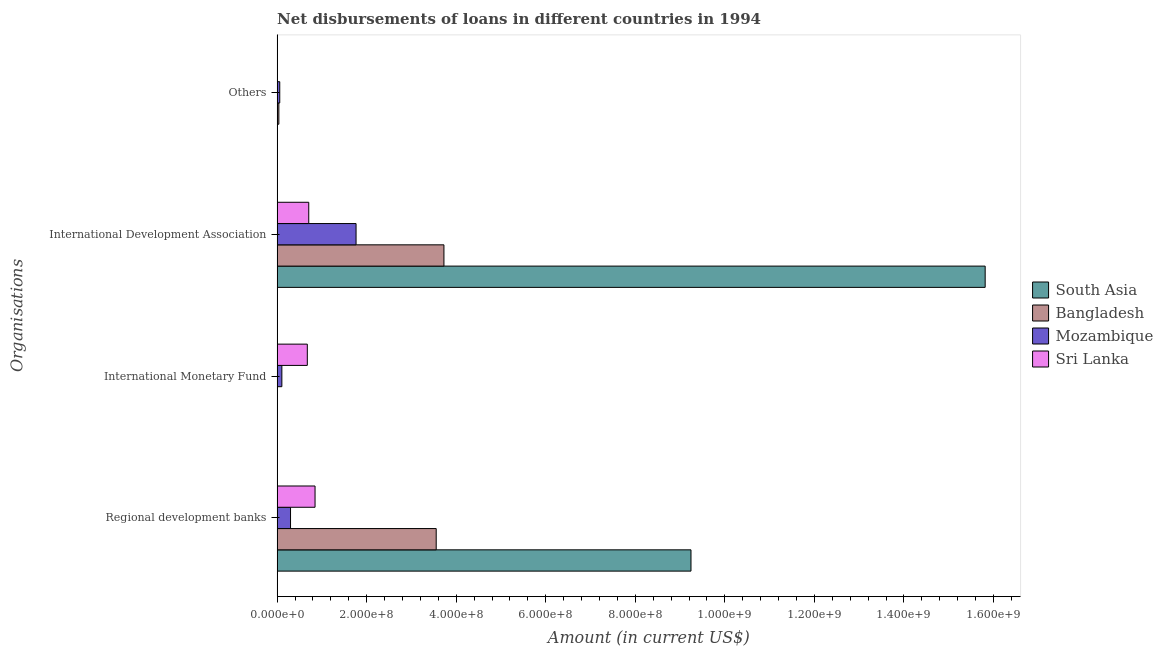How many different coloured bars are there?
Provide a short and direct response. 4. How many groups of bars are there?
Keep it short and to the point. 4. How many bars are there on the 1st tick from the top?
Your answer should be very brief. 2. How many bars are there on the 1st tick from the bottom?
Your response must be concise. 4. What is the label of the 4th group of bars from the top?
Provide a short and direct response. Regional development banks. What is the amount of loan disimbursed by other organisations in Bangladesh?
Ensure brevity in your answer.  3.88e+06. Across all countries, what is the maximum amount of loan disimbursed by international monetary fund?
Provide a succinct answer. 6.74e+07. Across all countries, what is the minimum amount of loan disimbursed by other organisations?
Your answer should be very brief. 0. In which country was the amount of loan disimbursed by international development association maximum?
Provide a short and direct response. South Asia. What is the total amount of loan disimbursed by international monetary fund in the graph?
Keep it short and to the point. 7.80e+07. What is the difference between the amount of loan disimbursed by regional development banks in Mozambique and that in South Asia?
Provide a succinct answer. -8.94e+08. What is the difference between the amount of loan disimbursed by international monetary fund in Mozambique and the amount of loan disimbursed by international development association in Sri Lanka?
Your answer should be compact. -6.01e+07. What is the average amount of loan disimbursed by other organisations per country?
Offer a terse response. 2.44e+06. What is the difference between the amount of loan disimbursed by international development association and amount of loan disimbursed by regional development banks in Bangladesh?
Offer a terse response. 1.73e+07. In how many countries, is the amount of loan disimbursed by international monetary fund greater than 1040000000 US$?
Provide a succinct answer. 0. What is the ratio of the amount of loan disimbursed by regional development banks in South Asia to that in Sri Lanka?
Keep it short and to the point. 10.91. Is the amount of loan disimbursed by other organisations in Bangladesh less than that in Mozambique?
Keep it short and to the point. Yes. What is the difference between the highest and the second highest amount of loan disimbursed by international development association?
Your answer should be very brief. 1.21e+09. What is the difference between the highest and the lowest amount of loan disimbursed by international monetary fund?
Your answer should be very brief. 6.74e+07. How many bars are there?
Your answer should be very brief. 12. Are all the bars in the graph horizontal?
Keep it short and to the point. Yes. What is the difference between two consecutive major ticks on the X-axis?
Make the answer very short. 2.00e+08. Does the graph contain any zero values?
Offer a very short reply. Yes. Does the graph contain grids?
Give a very brief answer. No. Where does the legend appear in the graph?
Provide a short and direct response. Center right. How are the legend labels stacked?
Your response must be concise. Vertical. What is the title of the graph?
Make the answer very short. Net disbursements of loans in different countries in 1994. Does "Dominica" appear as one of the legend labels in the graph?
Offer a terse response. No. What is the label or title of the X-axis?
Your answer should be very brief. Amount (in current US$). What is the label or title of the Y-axis?
Your response must be concise. Organisations. What is the Amount (in current US$) in South Asia in Regional development banks?
Give a very brief answer. 9.24e+08. What is the Amount (in current US$) of Bangladesh in Regional development banks?
Offer a terse response. 3.55e+08. What is the Amount (in current US$) in Mozambique in Regional development banks?
Give a very brief answer. 2.99e+07. What is the Amount (in current US$) of Sri Lanka in Regional development banks?
Keep it short and to the point. 8.47e+07. What is the Amount (in current US$) of South Asia in International Monetary Fund?
Make the answer very short. 0. What is the Amount (in current US$) of Bangladesh in International Monetary Fund?
Your answer should be compact. 0. What is the Amount (in current US$) of Mozambique in International Monetary Fund?
Ensure brevity in your answer.  1.06e+07. What is the Amount (in current US$) of Sri Lanka in International Monetary Fund?
Your answer should be compact. 6.74e+07. What is the Amount (in current US$) of South Asia in International Development Association?
Your answer should be very brief. 1.58e+09. What is the Amount (in current US$) of Bangladesh in International Development Association?
Keep it short and to the point. 3.73e+08. What is the Amount (in current US$) in Mozambique in International Development Association?
Keep it short and to the point. 1.76e+08. What is the Amount (in current US$) of Sri Lanka in International Development Association?
Make the answer very short. 7.06e+07. What is the Amount (in current US$) of Bangladesh in Others?
Provide a short and direct response. 3.88e+06. What is the Amount (in current US$) in Mozambique in Others?
Offer a terse response. 5.87e+06. What is the Amount (in current US$) of Sri Lanka in Others?
Give a very brief answer. 0. Across all Organisations, what is the maximum Amount (in current US$) in South Asia?
Ensure brevity in your answer.  1.58e+09. Across all Organisations, what is the maximum Amount (in current US$) in Bangladesh?
Offer a terse response. 3.73e+08. Across all Organisations, what is the maximum Amount (in current US$) in Mozambique?
Ensure brevity in your answer.  1.76e+08. Across all Organisations, what is the maximum Amount (in current US$) of Sri Lanka?
Offer a very short reply. 8.47e+07. Across all Organisations, what is the minimum Amount (in current US$) of South Asia?
Keep it short and to the point. 0. Across all Organisations, what is the minimum Amount (in current US$) in Bangladesh?
Offer a very short reply. 0. Across all Organisations, what is the minimum Amount (in current US$) in Mozambique?
Offer a very short reply. 5.87e+06. What is the total Amount (in current US$) of South Asia in the graph?
Make the answer very short. 2.51e+09. What is the total Amount (in current US$) in Bangladesh in the graph?
Your answer should be very brief. 7.32e+08. What is the total Amount (in current US$) in Mozambique in the graph?
Your response must be concise. 2.23e+08. What is the total Amount (in current US$) of Sri Lanka in the graph?
Offer a very short reply. 2.23e+08. What is the difference between the Amount (in current US$) of Mozambique in Regional development banks and that in International Monetary Fund?
Your answer should be very brief. 1.94e+07. What is the difference between the Amount (in current US$) in Sri Lanka in Regional development banks and that in International Monetary Fund?
Make the answer very short. 1.73e+07. What is the difference between the Amount (in current US$) in South Asia in Regional development banks and that in International Development Association?
Make the answer very short. -6.57e+08. What is the difference between the Amount (in current US$) of Bangladesh in Regional development banks and that in International Development Association?
Make the answer very short. -1.73e+07. What is the difference between the Amount (in current US$) in Mozambique in Regional development banks and that in International Development Association?
Provide a succinct answer. -1.46e+08. What is the difference between the Amount (in current US$) in Sri Lanka in Regional development banks and that in International Development Association?
Your response must be concise. 1.41e+07. What is the difference between the Amount (in current US$) in Bangladesh in Regional development banks and that in Others?
Your answer should be compact. 3.51e+08. What is the difference between the Amount (in current US$) in Mozambique in Regional development banks and that in Others?
Give a very brief answer. 2.41e+07. What is the difference between the Amount (in current US$) of Mozambique in International Monetary Fund and that in International Development Association?
Give a very brief answer. -1.66e+08. What is the difference between the Amount (in current US$) of Sri Lanka in International Monetary Fund and that in International Development Association?
Your answer should be compact. -3.22e+06. What is the difference between the Amount (in current US$) in Mozambique in International Monetary Fund and that in Others?
Keep it short and to the point. 4.70e+06. What is the difference between the Amount (in current US$) in Bangladesh in International Development Association and that in Others?
Keep it short and to the point. 3.69e+08. What is the difference between the Amount (in current US$) of Mozambique in International Development Association and that in Others?
Your answer should be very brief. 1.70e+08. What is the difference between the Amount (in current US$) of South Asia in Regional development banks and the Amount (in current US$) of Mozambique in International Monetary Fund?
Offer a terse response. 9.14e+08. What is the difference between the Amount (in current US$) in South Asia in Regional development banks and the Amount (in current US$) in Sri Lanka in International Monetary Fund?
Your answer should be compact. 8.57e+08. What is the difference between the Amount (in current US$) in Bangladesh in Regional development banks and the Amount (in current US$) in Mozambique in International Monetary Fund?
Make the answer very short. 3.45e+08. What is the difference between the Amount (in current US$) of Bangladesh in Regional development banks and the Amount (in current US$) of Sri Lanka in International Monetary Fund?
Ensure brevity in your answer.  2.88e+08. What is the difference between the Amount (in current US$) of Mozambique in Regional development banks and the Amount (in current US$) of Sri Lanka in International Monetary Fund?
Provide a succinct answer. -3.75e+07. What is the difference between the Amount (in current US$) of South Asia in Regional development banks and the Amount (in current US$) of Bangladesh in International Development Association?
Make the answer very short. 5.52e+08. What is the difference between the Amount (in current US$) in South Asia in Regional development banks and the Amount (in current US$) in Mozambique in International Development Association?
Keep it short and to the point. 7.48e+08. What is the difference between the Amount (in current US$) of South Asia in Regional development banks and the Amount (in current US$) of Sri Lanka in International Development Association?
Make the answer very short. 8.54e+08. What is the difference between the Amount (in current US$) of Bangladesh in Regional development banks and the Amount (in current US$) of Mozambique in International Development Association?
Ensure brevity in your answer.  1.79e+08. What is the difference between the Amount (in current US$) of Bangladesh in Regional development banks and the Amount (in current US$) of Sri Lanka in International Development Association?
Give a very brief answer. 2.85e+08. What is the difference between the Amount (in current US$) of Mozambique in Regional development banks and the Amount (in current US$) of Sri Lanka in International Development Association?
Keep it short and to the point. -4.07e+07. What is the difference between the Amount (in current US$) of South Asia in Regional development banks and the Amount (in current US$) of Bangladesh in Others?
Your answer should be very brief. 9.21e+08. What is the difference between the Amount (in current US$) in South Asia in Regional development banks and the Amount (in current US$) in Mozambique in Others?
Provide a short and direct response. 9.19e+08. What is the difference between the Amount (in current US$) of Bangladesh in Regional development banks and the Amount (in current US$) of Mozambique in Others?
Offer a terse response. 3.49e+08. What is the difference between the Amount (in current US$) of Mozambique in International Monetary Fund and the Amount (in current US$) of Sri Lanka in International Development Association?
Provide a succinct answer. -6.01e+07. What is the difference between the Amount (in current US$) in South Asia in International Development Association and the Amount (in current US$) in Bangladesh in Others?
Keep it short and to the point. 1.58e+09. What is the difference between the Amount (in current US$) of South Asia in International Development Association and the Amount (in current US$) of Mozambique in Others?
Give a very brief answer. 1.58e+09. What is the difference between the Amount (in current US$) of Bangladesh in International Development Association and the Amount (in current US$) of Mozambique in Others?
Offer a terse response. 3.67e+08. What is the average Amount (in current US$) of South Asia per Organisations?
Provide a succinct answer. 6.26e+08. What is the average Amount (in current US$) in Bangladesh per Organisations?
Provide a succinct answer. 1.83e+08. What is the average Amount (in current US$) in Mozambique per Organisations?
Your response must be concise. 5.57e+07. What is the average Amount (in current US$) of Sri Lanka per Organisations?
Keep it short and to the point. 5.57e+07. What is the difference between the Amount (in current US$) in South Asia and Amount (in current US$) in Bangladesh in Regional development banks?
Offer a very short reply. 5.69e+08. What is the difference between the Amount (in current US$) of South Asia and Amount (in current US$) of Mozambique in Regional development banks?
Provide a succinct answer. 8.94e+08. What is the difference between the Amount (in current US$) of South Asia and Amount (in current US$) of Sri Lanka in Regional development banks?
Offer a very short reply. 8.40e+08. What is the difference between the Amount (in current US$) of Bangladesh and Amount (in current US$) of Mozambique in Regional development banks?
Offer a very short reply. 3.25e+08. What is the difference between the Amount (in current US$) of Bangladesh and Amount (in current US$) of Sri Lanka in Regional development banks?
Your answer should be compact. 2.71e+08. What is the difference between the Amount (in current US$) of Mozambique and Amount (in current US$) of Sri Lanka in Regional development banks?
Provide a succinct answer. -5.48e+07. What is the difference between the Amount (in current US$) of Mozambique and Amount (in current US$) of Sri Lanka in International Monetary Fund?
Your answer should be compact. -5.68e+07. What is the difference between the Amount (in current US$) in South Asia and Amount (in current US$) in Bangladesh in International Development Association?
Your response must be concise. 1.21e+09. What is the difference between the Amount (in current US$) in South Asia and Amount (in current US$) in Mozambique in International Development Association?
Your response must be concise. 1.41e+09. What is the difference between the Amount (in current US$) in South Asia and Amount (in current US$) in Sri Lanka in International Development Association?
Offer a terse response. 1.51e+09. What is the difference between the Amount (in current US$) in Bangladesh and Amount (in current US$) in Mozambique in International Development Association?
Give a very brief answer. 1.96e+08. What is the difference between the Amount (in current US$) in Bangladesh and Amount (in current US$) in Sri Lanka in International Development Association?
Your response must be concise. 3.02e+08. What is the difference between the Amount (in current US$) of Mozambique and Amount (in current US$) of Sri Lanka in International Development Association?
Provide a succinct answer. 1.06e+08. What is the difference between the Amount (in current US$) in Bangladesh and Amount (in current US$) in Mozambique in Others?
Make the answer very short. -1.98e+06. What is the ratio of the Amount (in current US$) of Mozambique in Regional development banks to that in International Monetary Fund?
Your response must be concise. 2.83. What is the ratio of the Amount (in current US$) of Sri Lanka in Regional development banks to that in International Monetary Fund?
Make the answer very short. 1.26. What is the ratio of the Amount (in current US$) of South Asia in Regional development banks to that in International Development Association?
Your response must be concise. 0.58. What is the ratio of the Amount (in current US$) in Bangladesh in Regional development banks to that in International Development Association?
Offer a very short reply. 0.95. What is the ratio of the Amount (in current US$) in Mozambique in Regional development banks to that in International Development Association?
Offer a terse response. 0.17. What is the ratio of the Amount (in current US$) of Sri Lanka in Regional development banks to that in International Development Association?
Offer a very short reply. 1.2. What is the ratio of the Amount (in current US$) of Bangladesh in Regional development banks to that in Others?
Your response must be concise. 91.48. What is the ratio of the Amount (in current US$) of Mozambique in Regional development banks to that in Others?
Give a very brief answer. 5.1. What is the ratio of the Amount (in current US$) of Mozambique in International Monetary Fund to that in International Development Association?
Offer a terse response. 0.06. What is the ratio of the Amount (in current US$) of Sri Lanka in International Monetary Fund to that in International Development Association?
Make the answer very short. 0.95. What is the ratio of the Amount (in current US$) in Mozambique in International Monetary Fund to that in Others?
Your answer should be very brief. 1.8. What is the ratio of the Amount (in current US$) in Bangladesh in International Development Association to that in Others?
Provide a short and direct response. 95.93. What is the ratio of the Amount (in current US$) of Mozambique in International Development Association to that in Others?
Offer a terse response. 30.05. What is the difference between the highest and the second highest Amount (in current US$) in Bangladesh?
Offer a very short reply. 1.73e+07. What is the difference between the highest and the second highest Amount (in current US$) of Mozambique?
Give a very brief answer. 1.46e+08. What is the difference between the highest and the second highest Amount (in current US$) of Sri Lanka?
Your answer should be compact. 1.41e+07. What is the difference between the highest and the lowest Amount (in current US$) of South Asia?
Give a very brief answer. 1.58e+09. What is the difference between the highest and the lowest Amount (in current US$) of Bangladesh?
Ensure brevity in your answer.  3.73e+08. What is the difference between the highest and the lowest Amount (in current US$) of Mozambique?
Offer a very short reply. 1.70e+08. What is the difference between the highest and the lowest Amount (in current US$) of Sri Lanka?
Give a very brief answer. 8.47e+07. 